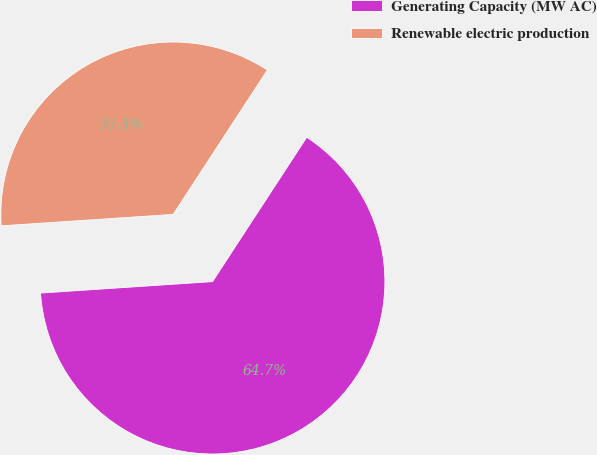Convert chart to OTSL. <chart><loc_0><loc_0><loc_500><loc_500><pie_chart><fcel>Generating Capacity (MW AC)<fcel>Renewable electric production<nl><fcel>64.74%<fcel>35.26%<nl></chart> 